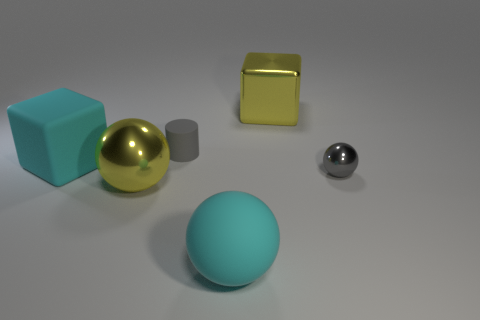Subtract all big spheres. How many spheres are left? 1 Add 4 small gray rubber things. How many objects exist? 10 Subtract all cubes. How many objects are left? 4 Subtract all cyan cubes. How many cubes are left? 1 Subtract all green balls. Subtract all cyan cylinders. How many balls are left? 3 Subtract all brown things. Subtract all small cylinders. How many objects are left? 5 Add 1 cyan blocks. How many cyan blocks are left? 2 Add 2 tiny gray objects. How many tiny gray objects exist? 4 Subtract 0 purple balls. How many objects are left? 6 